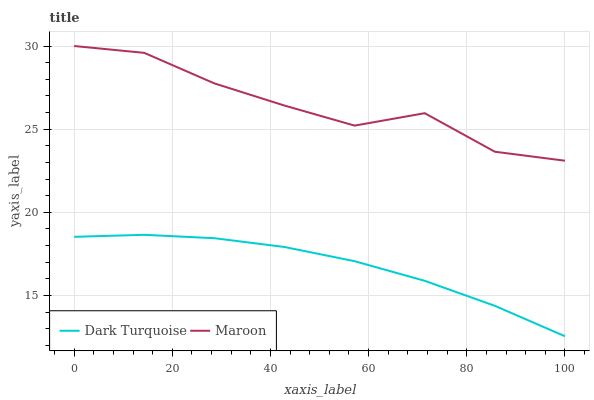Does Dark Turquoise have the minimum area under the curve?
Answer yes or no. Yes. Does Maroon have the maximum area under the curve?
Answer yes or no. Yes. Does Maroon have the minimum area under the curve?
Answer yes or no. No. Is Dark Turquoise the smoothest?
Answer yes or no. Yes. Is Maroon the roughest?
Answer yes or no. Yes. Is Maroon the smoothest?
Answer yes or no. No. Does Maroon have the lowest value?
Answer yes or no. No. Is Dark Turquoise less than Maroon?
Answer yes or no. Yes. Is Maroon greater than Dark Turquoise?
Answer yes or no. Yes. Does Dark Turquoise intersect Maroon?
Answer yes or no. No. 